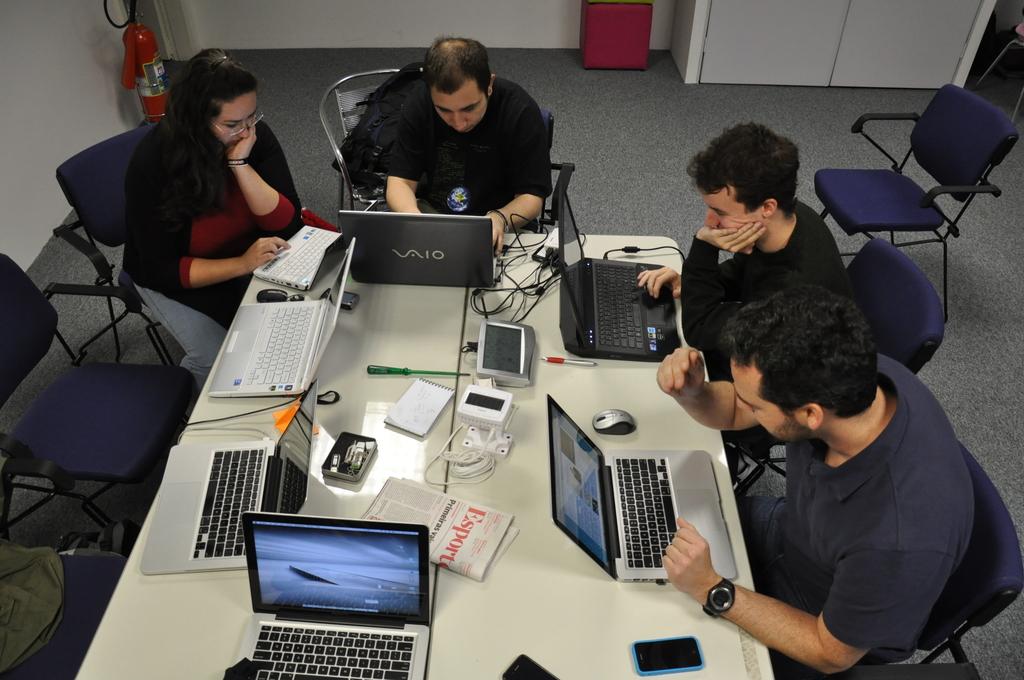What brand of computer are they using?
Offer a terse response. Vaio. What brand is the laptop?
Keep it short and to the point. Vaio. 